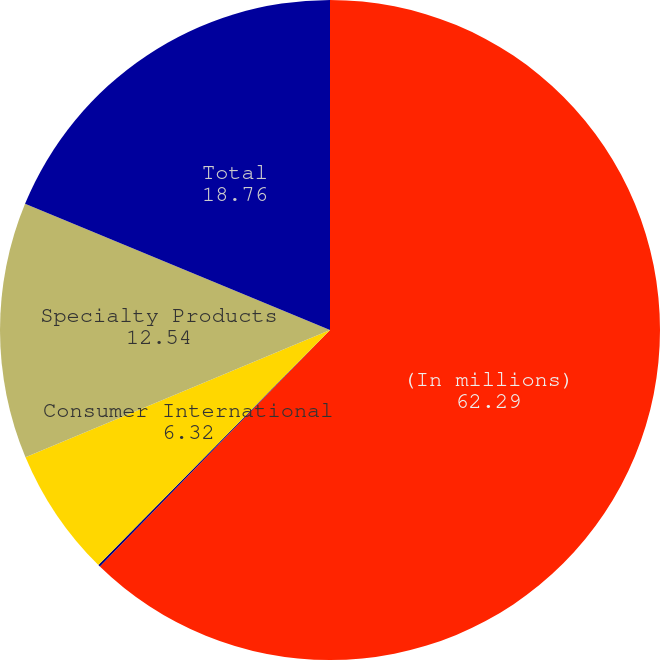Convert chart. <chart><loc_0><loc_0><loc_500><loc_500><pie_chart><fcel>(In millions)<fcel>Consumer Domestic<fcel>Consumer International<fcel>Specialty Products<fcel>Total<nl><fcel>62.29%<fcel>0.1%<fcel>6.32%<fcel>12.54%<fcel>18.76%<nl></chart> 